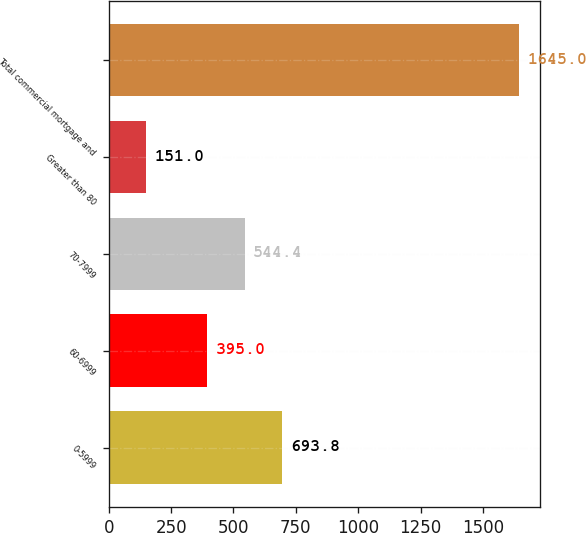Convert chart to OTSL. <chart><loc_0><loc_0><loc_500><loc_500><bar_chart><fcel>0-5999<fcel>60-6999<fcel>70-7999<fcel>Greater than 80<fcel>Total commercial mortgage and<nl><fcel>693.8<fcel>395<fcel>544.4<fcel>151<fcel>1645<nl></chart> 